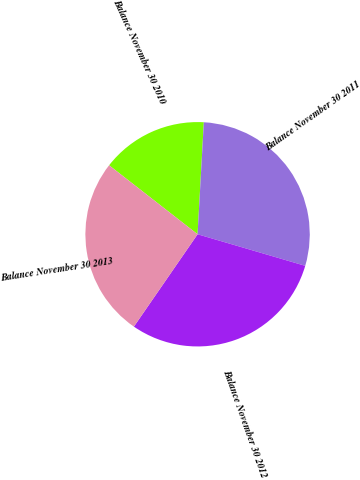<chart> <loc_0><loc_0><loc_500><loc_500><pie_chart><fcel>Balance November 30 2010<fcel>Balance November 30 2011<fcel>Balance November 30 2012<fcel>Balance November 30 2013<nl><fcel>15.35%<fcel>28.65%<fcel>30.07%<fcel>25.93%<nl></chart> 